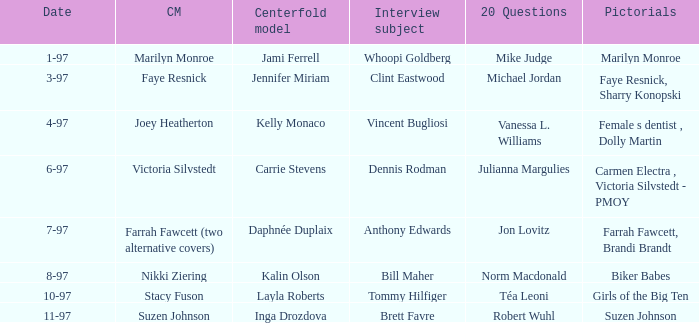Who was the interview subject on the date 1-97? Whoopi Goldberg. 